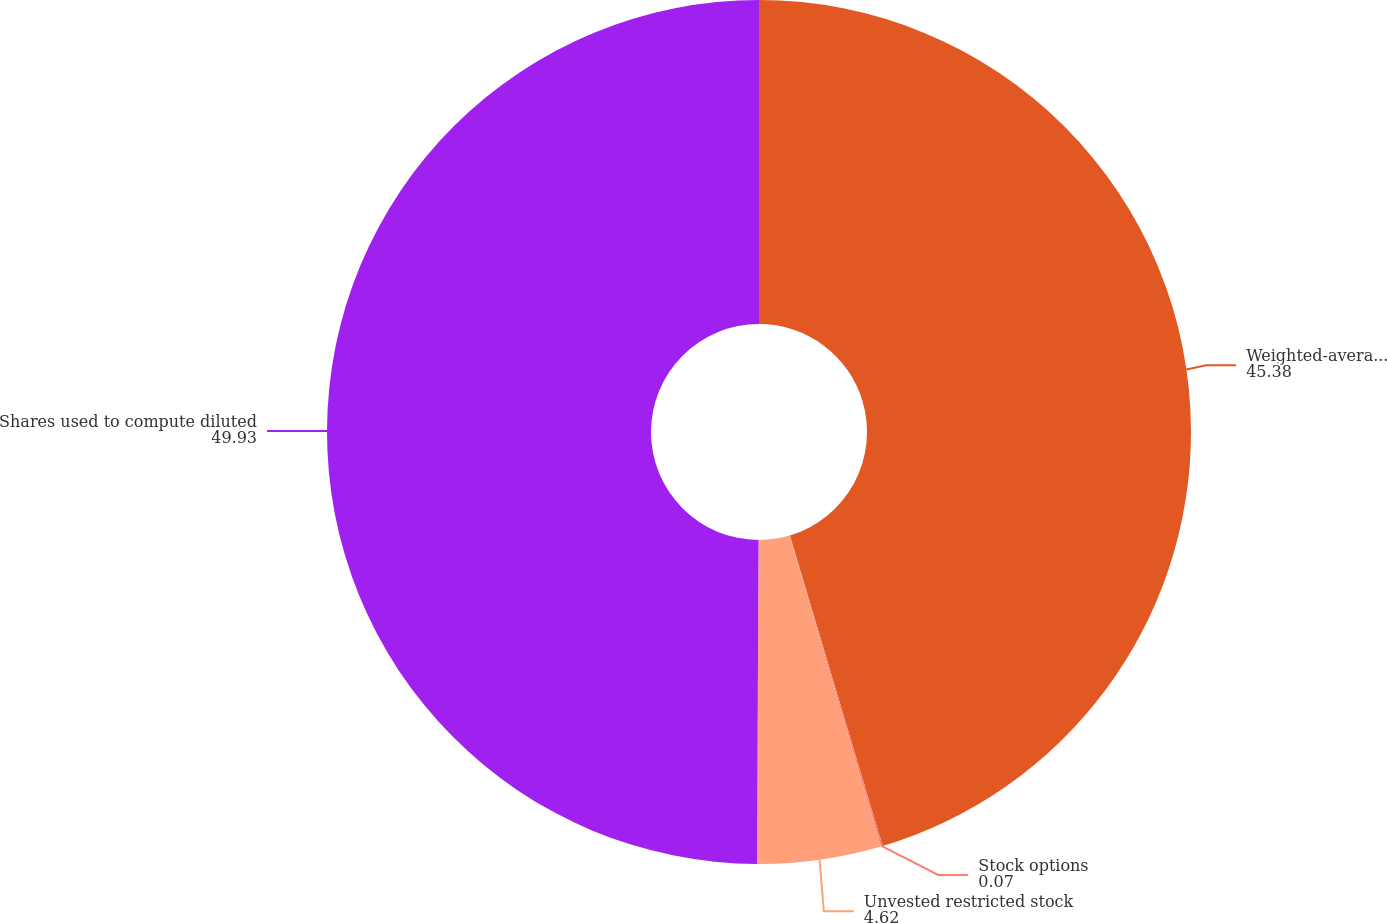Convert chart to OTSL. <chart><loc_0><loc_0><loc_500><loc_500><pie_chart><fcel>Weighted-average shares of<fcel>Stock options<fcel>Unvested restricted stock<fcel>Shares used to compute diluted<nl><fcel>45.38%<fcel>0.07%<fcel>4.62%<fcel>49.93%<nl></chart> 